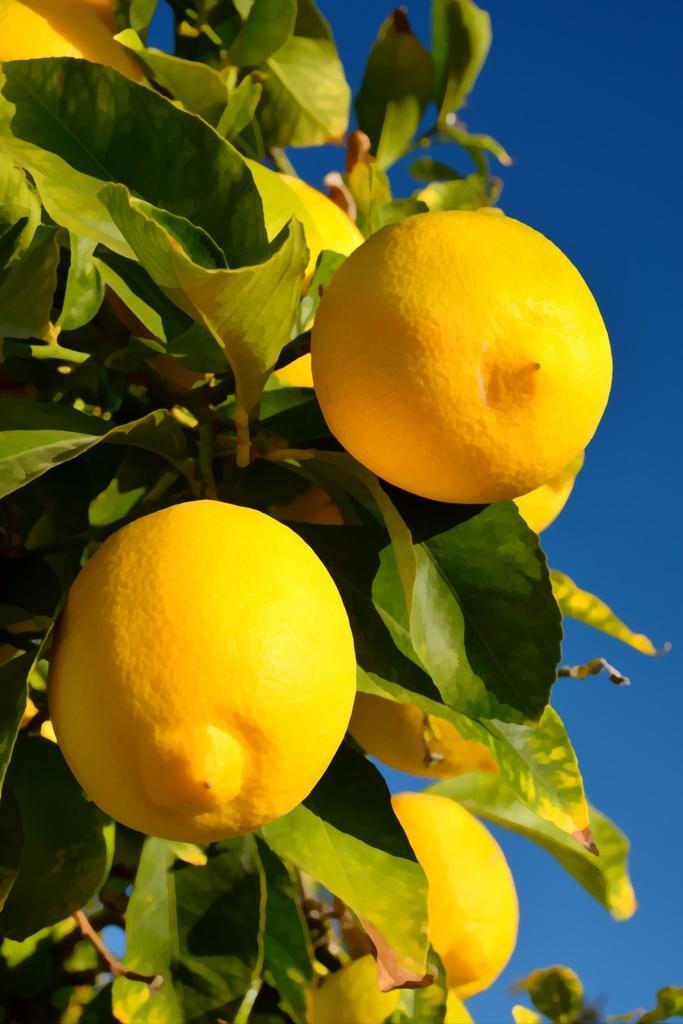Describe this image in one or two sentences. In this picture i can see yellow color fruits on plant. In the background i can see sky. 